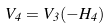<formula> <loc_0><loc_0><loc_500><loc_500>V _ { 4 } = V _ { 3 } ( - H _ { 4 } )</formula> 